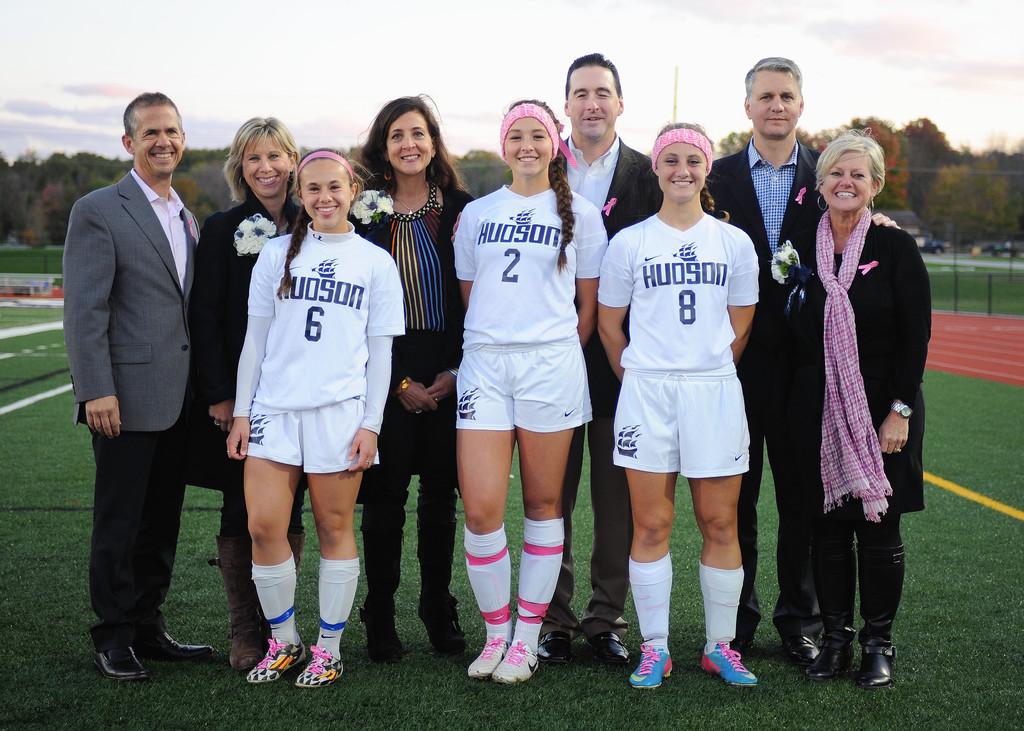What jersey number is the girl in the middle wearing?
Provide a succinct answer. 2. 